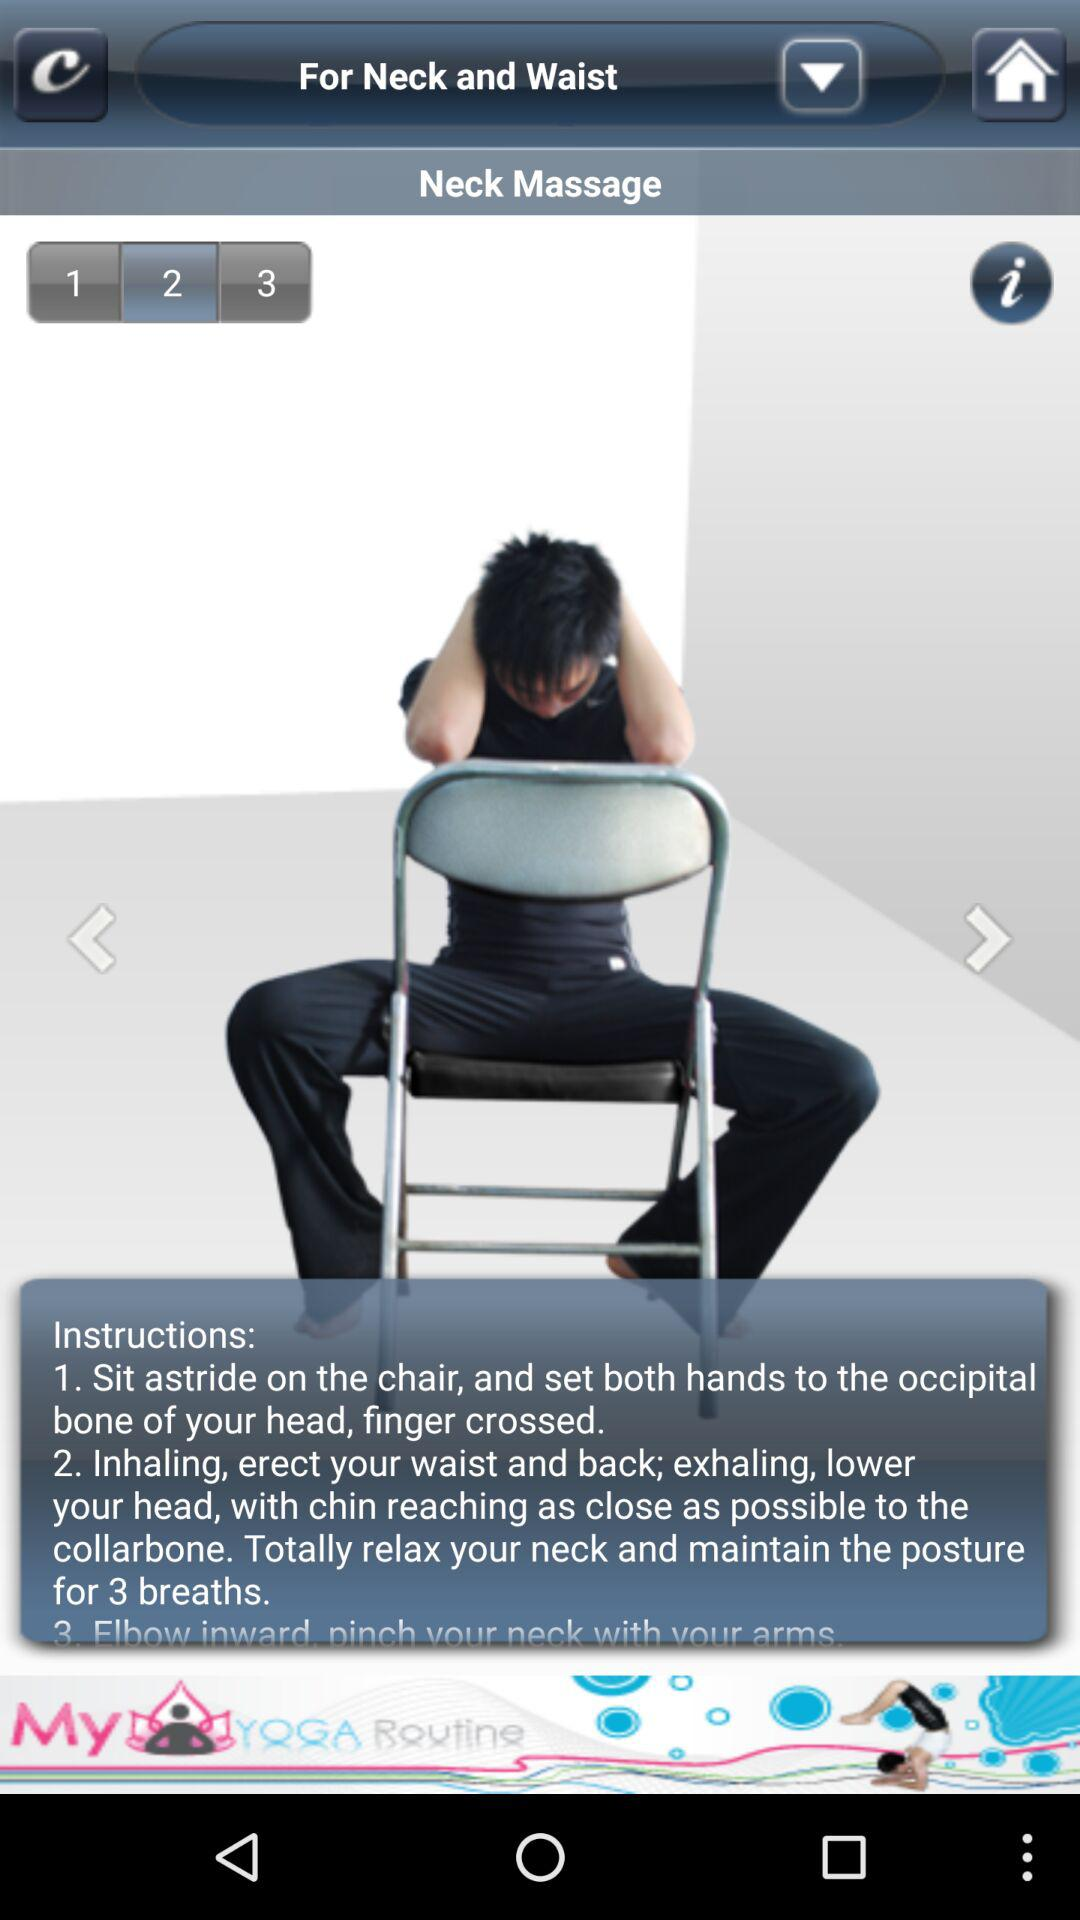What's the current selected exercise number? The current selected exercise number is 2. 